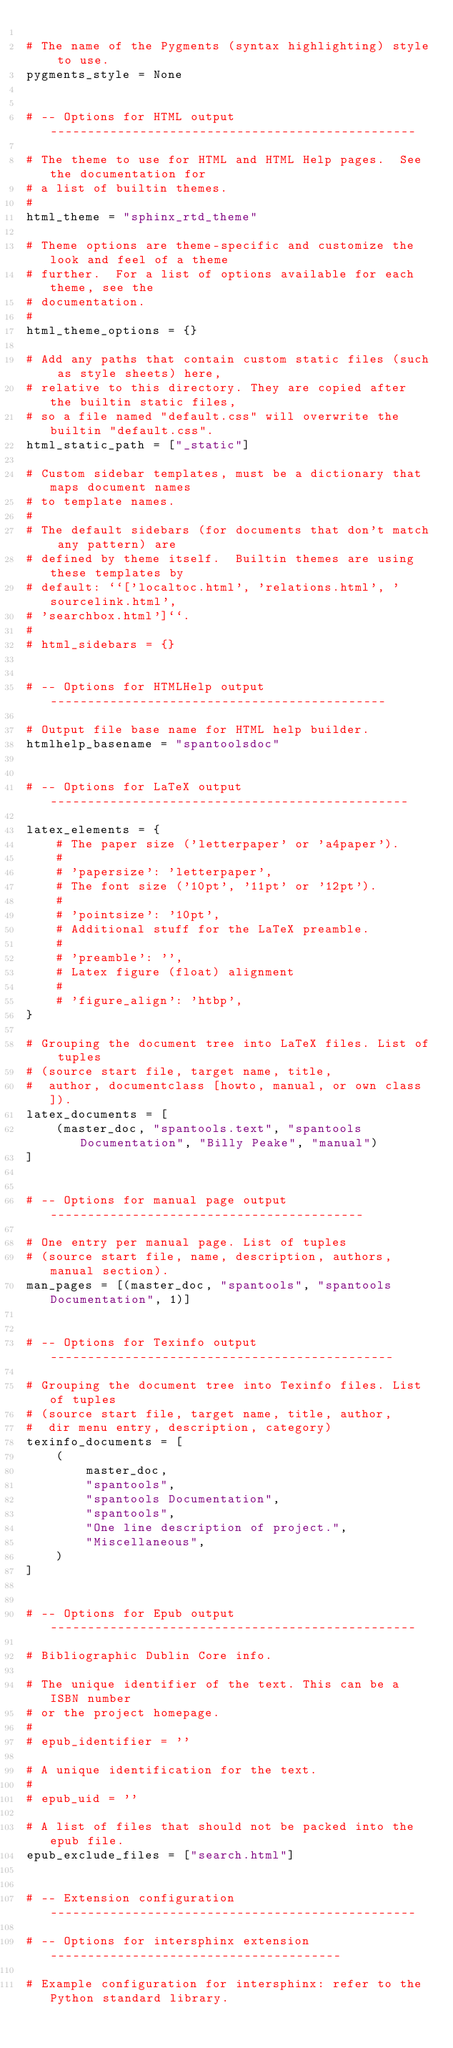Convert code to text. <code><loc_0><loc_0><loc_500><loc_500><_Python_>
# The name of the Pygments (syntax highlighting) style to use.
pygments_style = None


# -- Options for HTML output -------------------------------------------------

# The theme to use for HTML and HTML Help pages.  See the documentation for
# a list of builtin themes.
#
html_theme = "sphinx_rtd_theme"

# Theme options are theme-specific and customize the look and feel of a theme
# further.  For a list of options available for each theme, see the
# documentation.
#
html_theme_options = {}

# Add any paths that contain custom static files (such as style sheets) here,
# relative to this directory. They are copied after the builtin static files,
# so a file named "default.css" will overwrite the builtin "default.css".
html_static_path = ["_static"]

# Custom sidebar templates, must be a dictionary that maps document names
# to template names.
#
# The default sidebars (for documents that don't match any pattern) are
# defined by theme itself.  Builtin themes are using these templates by
# default: ``['localtoc.html', 'relations.html', 'sourcelink.html',
# 'searchbox.html']``.
#
# html_sidebars = {}


# -- Options for HTMLHelp output ---------------------------------------------

# Output file base name for HTML help builder.
htmlhelp_basename = "spantoolsdoc"


# -- Options for LaTeX output ------------------------------------------------

latex_elements = {
    # The paper size ('letterpaper' or 'a4paper').
    #
    # 'papersize': 'letterpaper',
    # The font size ('10pt', '11pt' or '12pt').
    #
    # 'pointsize': '10pt',
    # Additional stuff for the LaTeX preamble.
    #
    # 'preamble': '',
    # Latex figure (float) alignment
    #
    # 'figure_align': 'htbp',
}

# Grouping the document tree into LaTeX files. List of tuples
# (source start file, target name, title,
#  author, documentclass [howto, manual, or own class]).
latex_documents = [
    (master_doc, "spantools.text", "spantools Documentation", "Billy Peake", "manual")
]


# -- Options for manual page output ------------------------------------------

# One entry per manual page. List of tuples
# (source start file, name, description, authors, manual section).
man_pages = [(master_doc, "spantools", "spantools Documentation", 1)]


# -- Options for Texinfo output ----------------------------------------------

# Grouping the document tree into Texinfo files. List of tuples
# (source start file, target name, title, author,
#  dir menu entry, description, category)
texinfo_documents = [
    (
        master_doc,
        "spantools",
        "spantools Documentation",
        "spantools",
        "One line description of project.",
        "Miscellaneous",
    )
]


# -- Options for Epub output -------------------------------------------------

# Bibliographic Dublin Core info.

# The unique identifier of the text. This can be a ISBN number
# or the project homepage.
#
# epub_identifier = ''

# A unique identification for the text.
#
# epub_uid = ''

# A list of files that should not be packed into the epub file.
epub_exclude_files = ["search.html"]


# -- Extension configuration -------------------------------------------------

# -- Options for intersphinx extension ---------------------------------------

# Example configuration for intersphinx: refer to the Python standard library.</code> 